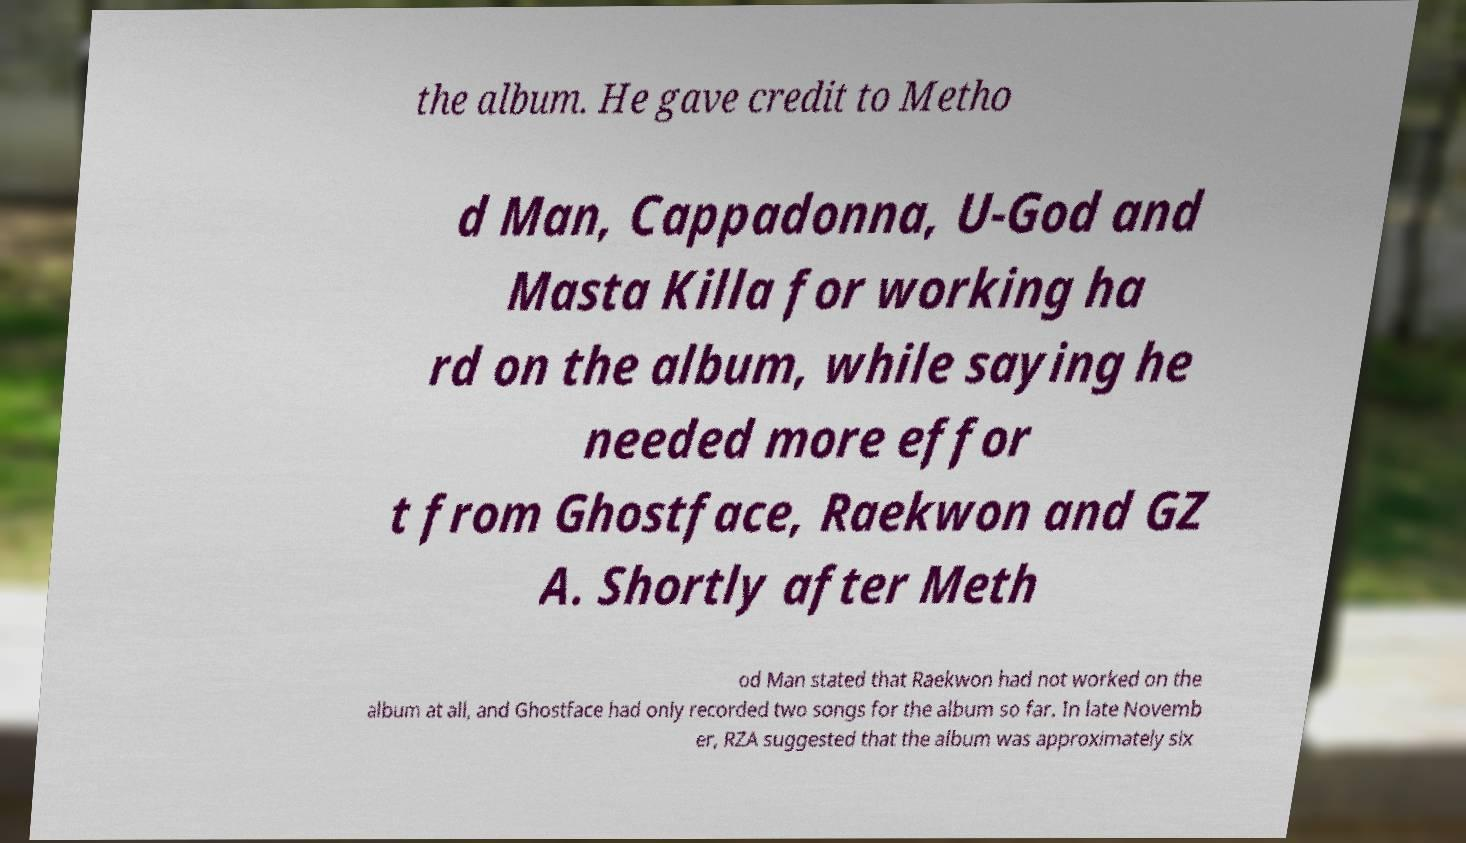I need the written content from this picture converted into text. Can you do that? the album. He gave credit to Metho d Man, Cappadonna, U-God and Masta Killa for working ha rd on the album, while saying he needed more effor t from Ghostface, Raekwon and GZ A. Shortly after Meth od Man stated that Raekwon had not worked on the album at all, and Ghostface had only recorded two songs for the album so far. In late Novemb er, RZA suggested that the album was approximately six 